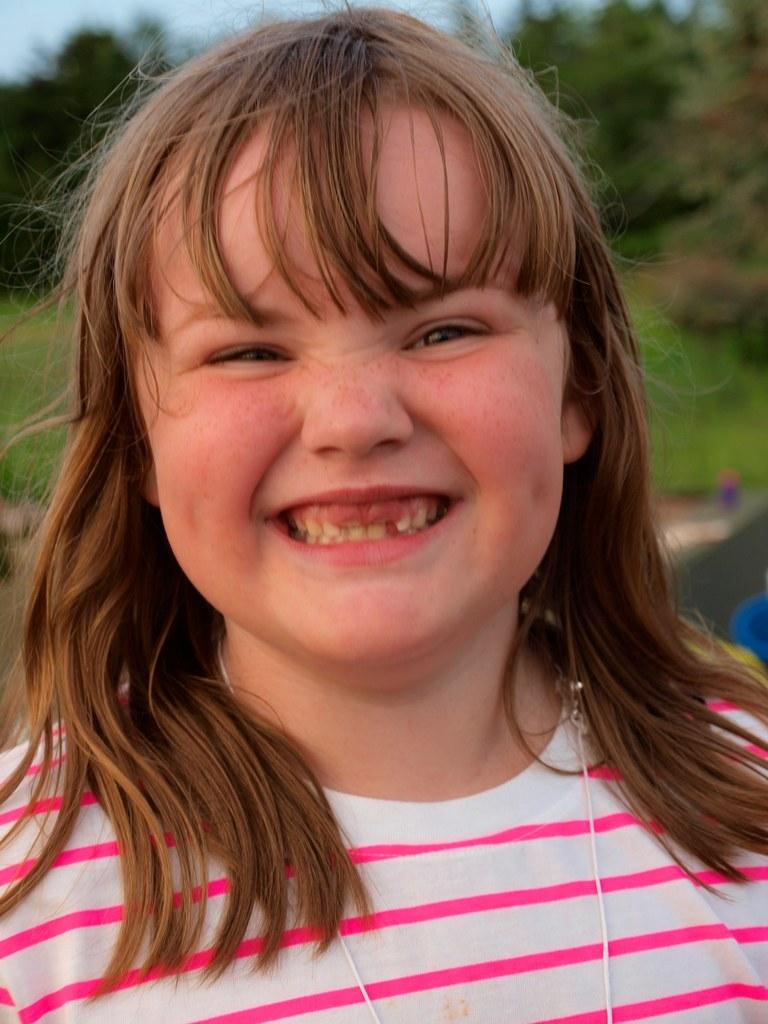Who is the main subject in the picture? There is a girl in the picture. What is the girl's expression in the picture? The girl is smiling. What can be seen in the background of the picture? There are trees in the background of the picture. Where is the oven located in the picture? There is no oven present in the picture. What type of cattle can be seen grazing in the background? There are no cattle present in the picture; it features a girl smiling in front of trees. 